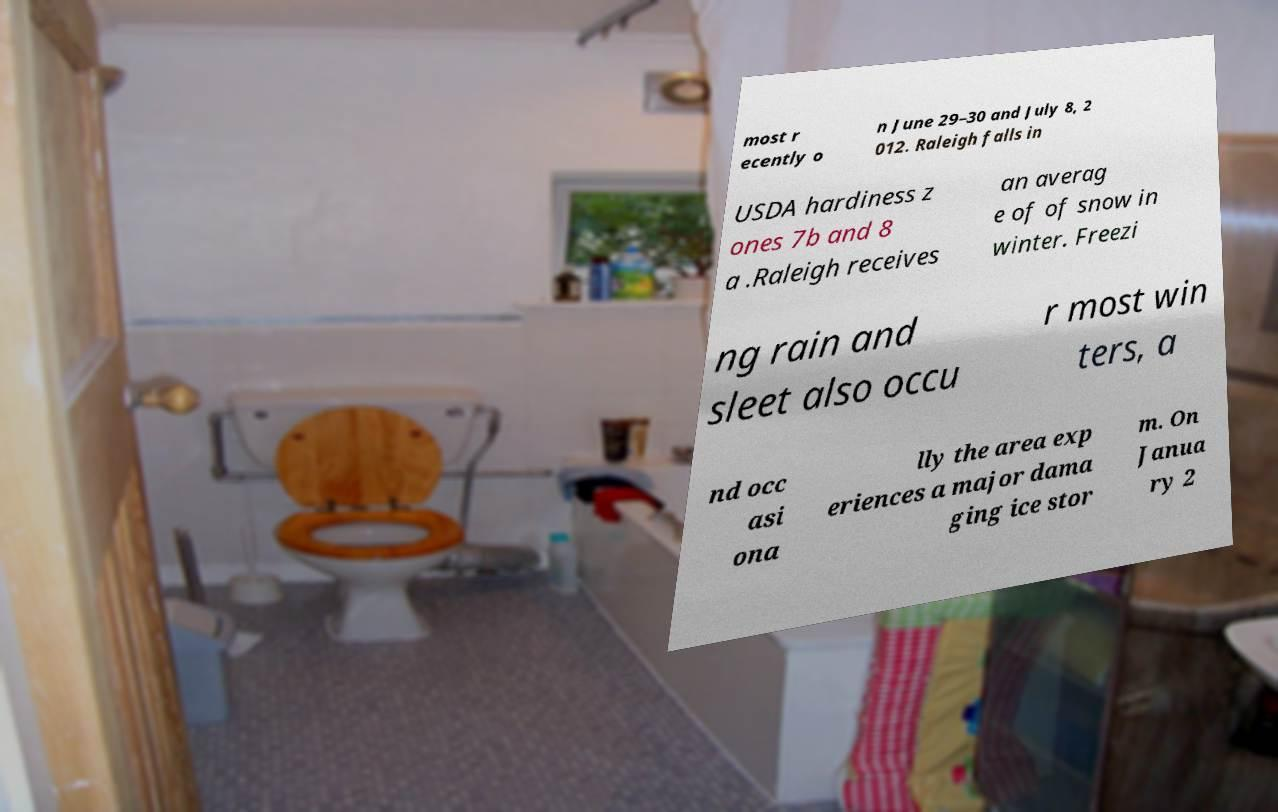Please identify and transcribe the text found in this image. most r ecently o n June 29–30 and July 8, 2 012. Raleigh falls in USDA hardiness z ones 7b and 8 a .Raleigh receives an averag e of of snow in winter. Freezi ng rain and sleet also occu r most win ters, a nd occ asi ona lly the area exp eriences a major dama ging ice stor m. On Janua ry 2 